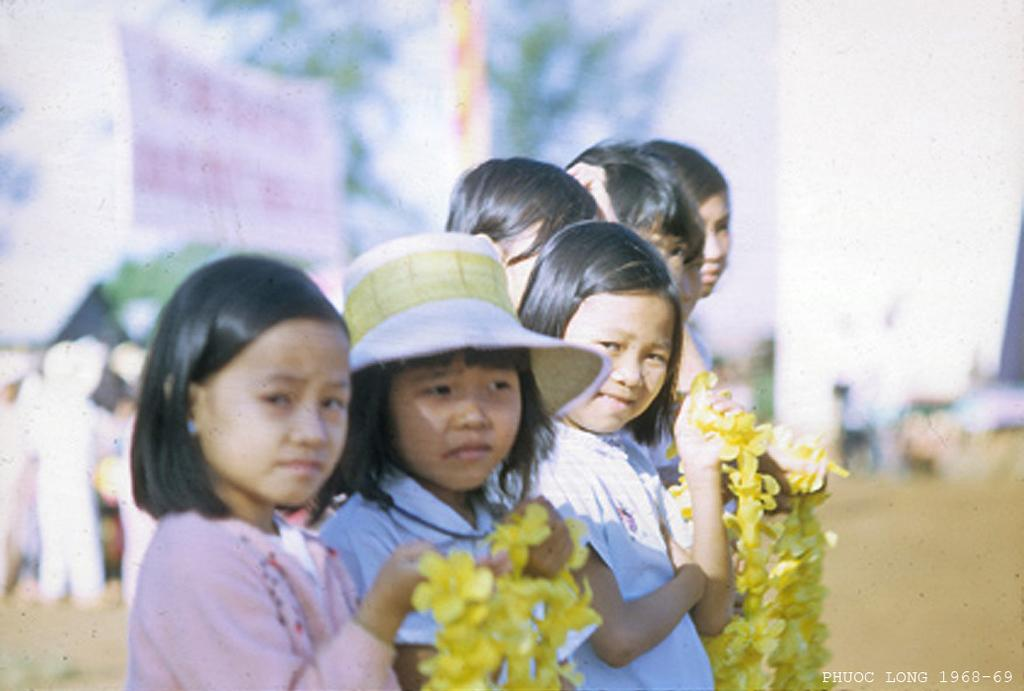What are the people in the image holding? The people in the image are holding garlands. Can you describe the background of the image? The background of the image is blurred. What type of pest can be seen crawling on the calendar in the image? There is no calendar or pest present in the image. 